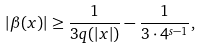Convert formula to latex. <formula><loc_0><loc_0><loc_500><loc_500>\left | \beta ( x ) \right | \geq \frac { 1 } { 3 q ( | x | ) } - \frac { 1 } { 3 \cdot 4 ^ { s - 1 } } ,</formula> 